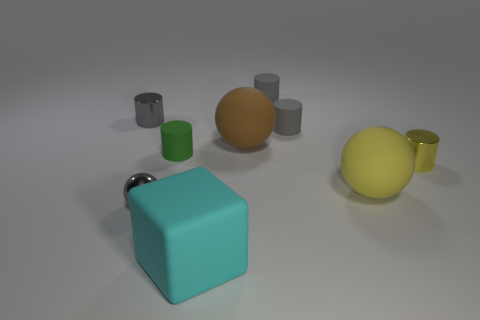What is the size of the matte cylinder to the left of the big cyan rubber cube?
Your answer should be very brief. Small. Do the gray metallic ball and the green matte cylinder have the same size?
Provide a short and direct response. Yes. What number of tiny objects are behind the small green cylinder and to the right of the small green object?
Your answer should be compact. 2. How many gray things are either small objects or tiny rubber cylinders?
Provide a succinct answer. 4. What number of matte things are either big cyan objects or tiny objects?
Your response must be concise. 4. Are there any rubber cylinders?
Provide a succinct answer. Yes. Is the cyan thing the same shape as the small yellow metal object?
Provide a short and direct response. No. How many large yellow matte things are to the left of the large brown matte sphere that is in front of the small gray rubber cylinder that is behind the tiny gray shiny cylinder?
Provide a short and direct response. 0. There is a tiny thing that is in front of the tiny green matte cylinder and on the right side of the large brown rubber ball; what is its material?
Offer a very short reply. Metal. What color is the large matte thing that is right of the matte block and in front of the green cylinder?
Provide a short and direct response. Yellow. 